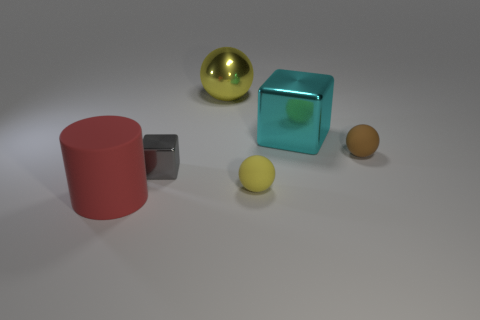What number of small matte cylinders are there?
Offer a very short reply. 0. What material is the yellow ball behind the cube that is to the right of the small yellow rubber object made of?
Your response must be concise. Metal. The small rubber thing that is to the left of the rubber object that is on the right side of the yellow thing in front of the small metallic thing is what color?
Keep it short and to the point. Yellow. Does the metallic ball have the same color as the tiny metallic cube?
Offer a very short reply. No. What number of cyan metal spheres have the same size as the cyan metal object?
Give a very brief answer. 0. Are there more small brown rubber objects right of the large red cylinder than small blocks that are behind the large ball?
Your answer should be very brief. Yes. What color is the small rubber ball that is behind the metal object that is in front of the brown sphere?
Offer a terse response. Brown. Is the material of the gray object the same as the small yellow thing?
Provide a succinct answer. No. Is there a small brown thing that has the same shape as the gray metallic object?
Offer a terse response. No. There is a tiny matte ball that is in front of the gray shiny thing; does it have the same color as the cylinder?
Ensure brevity in your answer.  No. 